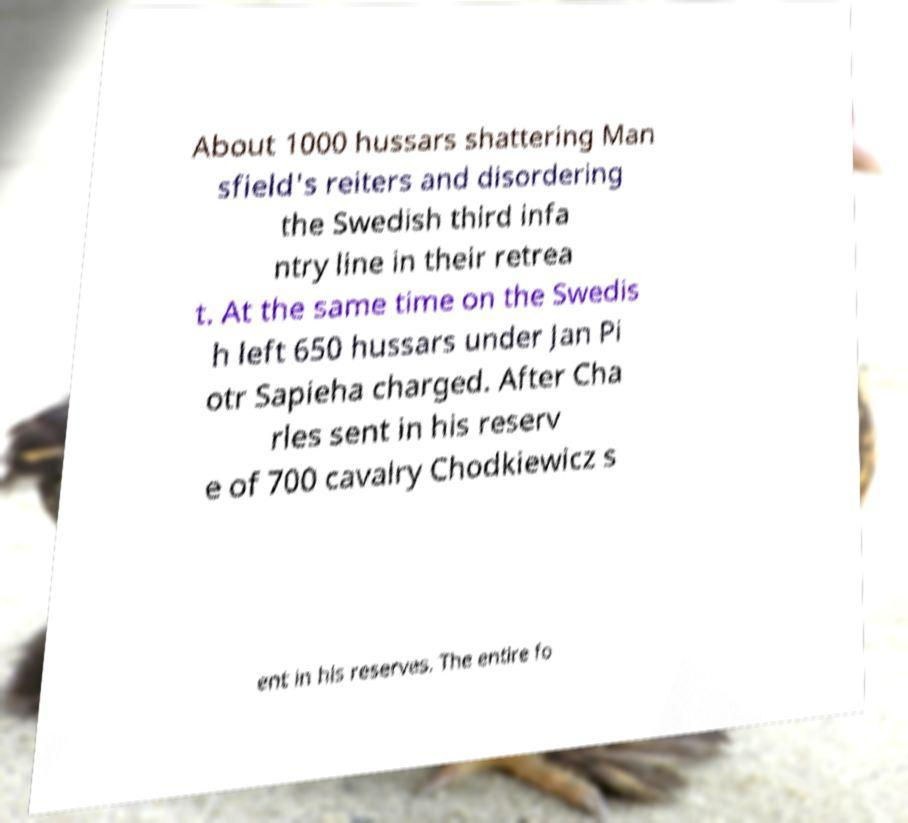I need the written content from this picture converted into text. Can you do that? About 1000 hussars shattering Man sfield's reiters and disordering the Swedish third infa ntry line in their retrea t. At the same time on the Swedis h left 650 hussars under Jan Pi otr Sapieha charged. After Cha rles sent in his reserv e of 700 cavalry Chodkiewicz s ent in his reserves. The entire fo 